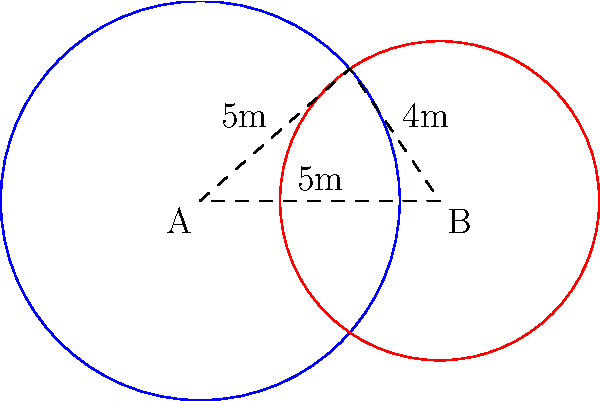In a Korean football league training facility, two circular training zones overlap on the practice field. Zone A has a radius of 5 meters, and Zone B has a radius of 4 meters. The centers of these zones are 6 meters apart. Calculate the area of the overlapping region between the two zones. Round your answer to the nearest square meter. To find the area of overlap between two circles, we can use the following steps:

1) First, we need to calculate the angle $\theta$ at the center of each circle formed by the line joining the centers and the line to an intersection point.

   For circle A: $\cos\theta_A = \frac{6^2 + 5^2 - 4^2}{2 \cdot 6 \cdot 5} = \frac{61}{60}$
   $\theta_A = \arccos(\frac{61}{60}) \approx 0.4636$ radians

   For circle B: $\cos\theta_B = \frac{6^2 + 4^2 - 5^2}{2 \cdot 6 \cdot 4} = \frac{11}{16}$
   $\theta_B = \arccos(\frac{11}{16}) \approx 1.0472$ radians

2) The area of a sector is given by $\frac{1}{2}r^2\theta$, where $r$ is the radius and $\theta$ is the angle in radians.

   Area of sector A = $\frac{1}{2} \cdot 5^2 \cdot 0.4636 = 5.795$ sq meters
   Area of sector B = $\frac{1}{2} \cdot 4^2 \cdot 1.0472 = 8.378$ sq meters

3) The area of the triangle formed by the centers and an intersection point:
   Area = $\frac{1}{2} \cdot 6 \cdot 5 \cdot \sin(0.4636) = 6.871$ sq meters

4) The overlapping area is the sum of the two sectors minus the area of the rhombus:
   Overlap area = $(5.795 + 8.378) - 2(6.871) = 0.431$ sq meters

5) Rounding to the nearest square meter: 0 sq meters
Answer: 0 sq meters 